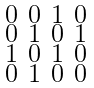Convert formula to latex. <formula><loc_0><loc_0><loc_500><loc_500>\begin{smallmatrix} 0 & 0 & 1 & 0 \\ 0 & 1 & 0 & 1 \\ 1 & 0 & 1 & 0 \\ 0 & 1 & 0 & 0 \end{smallmatrix}</formula> 